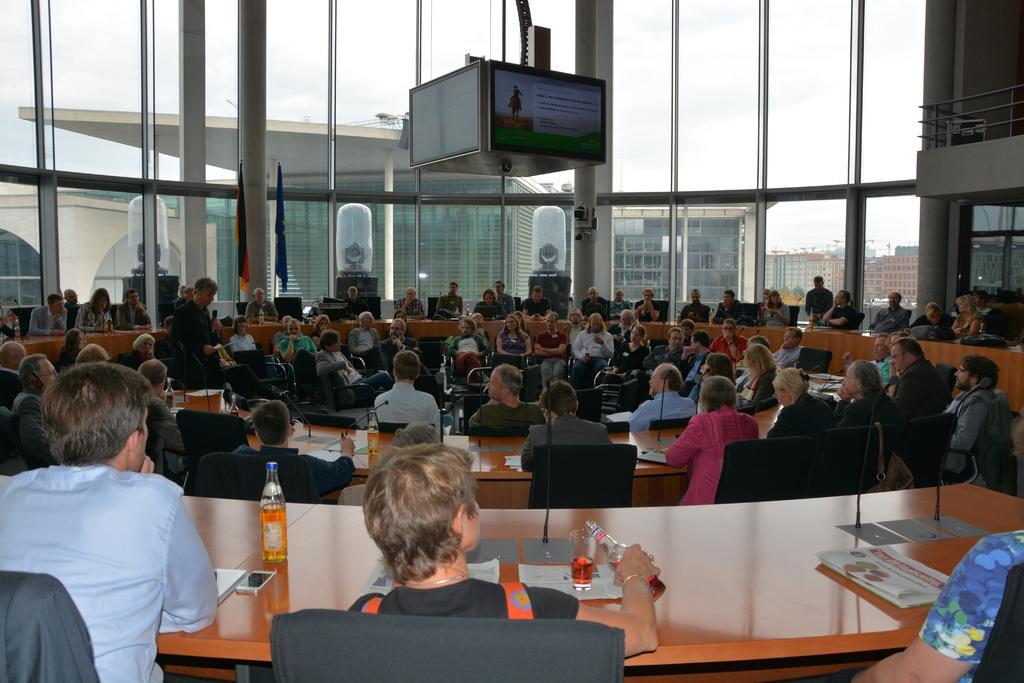How would you summarize this image in a sentence or two? In a picture we can see that, there are many people sitting in a circular table facing each other oppositely. This is a bench on which a glass and a bottle is kept. This are the microphones. 